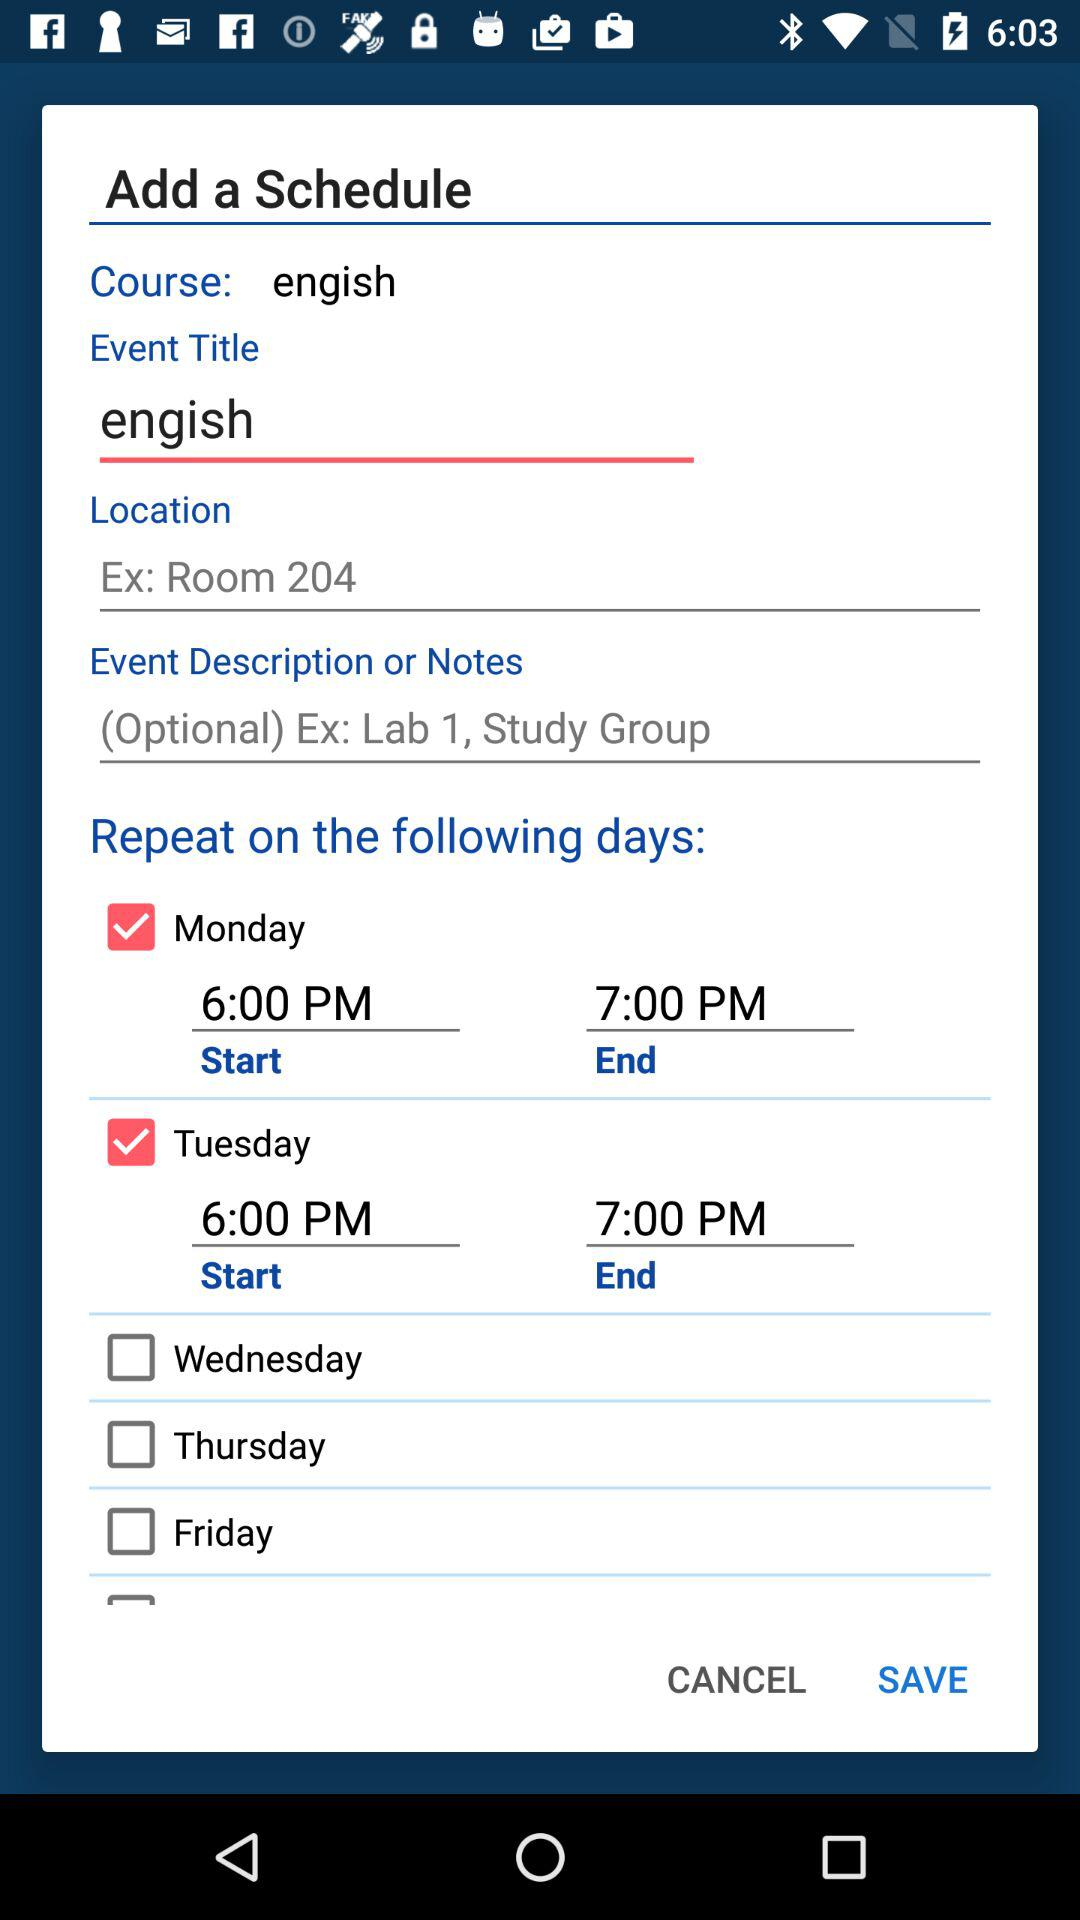What location is given as an example? The location that is given as an example is room 204. 